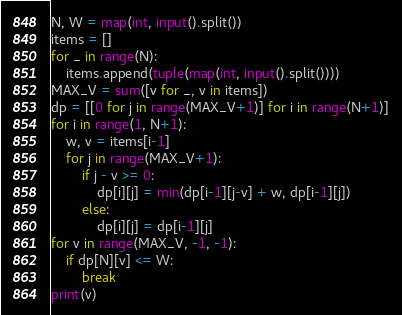Convert code to text. <code><loc_0><loc_0><loc_500><loc_500><_Python_>N, W = map(int, input().split())
items = []
for _ in range(N):
    items.append(tuple(map(int, input().split())))
MAX_V = sum([v for _, v in items])
dp = [[0 for j in range(MAX_V+1)] for i in range(N+1)]
for i in range(1, N+1):
    w, v = items[i-1]
    for j in range(MAX_V+1):
        if j - v >= 0:
            dp[i][j] = min(dp[i-1][j-v] + w, dp[i-1][j])
        else:
            dp[i][j] = dp[i-1][j]
for v in range(MAX_V, -1, -1):
    if dp[N][v] <= W:
        break
print(v)</code> 